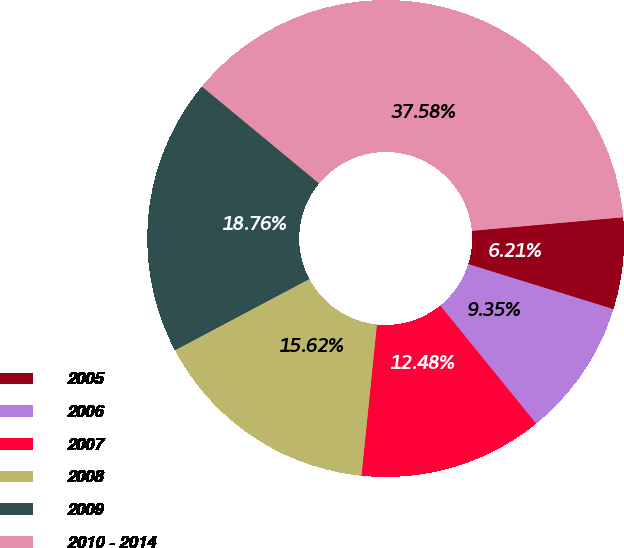Convert chart. <chart><loc_0><loc_0><loc_500><loc_500><pie_chart><fcel>2005<fcel>2006<fcel>2007<fcel>2008<fcel>2009<fcel>2010 - 2014<nl><fcel>6.21%<fcel>9.35%<fcel>12.48%<fcel>15.62%<fcel>18.76%<fcel>37.58%<nl></chart> 